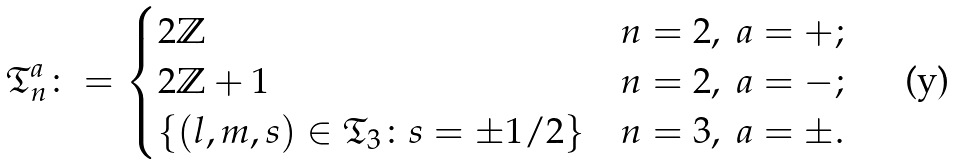Convert formula to latex. <formula><loc_0><loc_0><loc_500><loc_500>\mathfrak { T } ^ { a } _ { n } \colon = \begin{cases} 2 \mathbb { Z } & n = 2 , \ a = + ; \\ 2 \mathbb { Z } + 1 & n = 2 , \ a = - ; \\ \{ ( l , m , s ) \in \mathfrak { T } _ { 3 } \colon s = \pm 1 / 2 \} & n = 3 , \ a = \pm . \end{cases}</formula> 